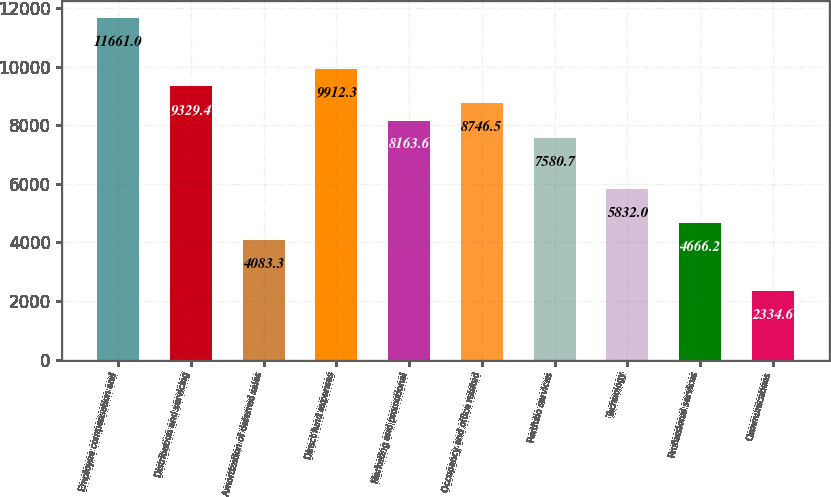Convert chart. <chart><loc_0><loc_0><loc_500><loc_500><bar_chart><fcel>Employee compensation and<fcel>Distribution and servicing<fcel>Amortization of deferred sales<fcel>Direct fund expenses<fcel>Marketing and promotional<fcel>Occupancy and office related<fcel>Portfolio services<fcel>Technology<fcel>Professional services<fcel>Communications<nl><fcel>11661<fcel>9329.4<fcel>4083.3<fcel>9912.3<fcel>8163.6<fcel>8746.5<fcel>7580.7<fcel>5832<fcel>4666.2<fcel>2334.6<nl></chart> 